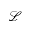<formula> <loc_0><loc_0><loc_500><loc_500>\mathcal { L }</formula> 